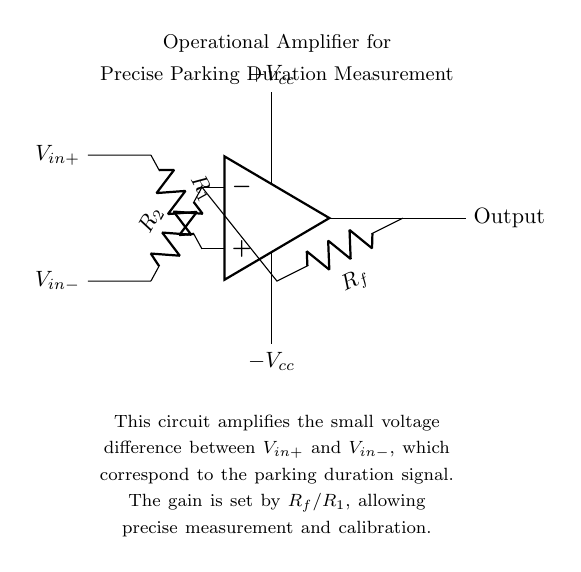What components are in the circuit? The circuit includes an operational amplifier, two resistors R1 and R2, and a feedback resistor Rf.
Answer: operational amplifier, R1, R2, Rf What is Vcc? Vcc refers to the positive power supply voltage connected to the operational amplifier's positive terminal.
Answer: positive power supply voltage What does the feedback resistor Rf do? Rf provides feedback to the inverting input of the operational amplifier, determining the gain of the amplifier.
Answer: determines the gain How is the gain of the amplifier calculated? The gain is calculated using the formula Rf divided by R1, where Rf is the feedback resistor and R1 is the resistor connected to the non-inverting input.
Answer: Rf/R1 What is the purpose of this circuit? The purpose is to amplify the voltage difference corresponding to parking duration for precise measurement.
Answer: amplify parking duration signal How does the output relate to the input? The output voltage from the operational amplifier reflects the amplified difference between the input voltages V_in+ and V_in-.
Answer: amplified difference between V_in+ and V_in- What is the role of the resistors R1 and R2? R1 and R2 set the input conditions for the non-inverting and inverting terminals of the operational amplifier, affecting the overall gain and stability of the circuit.
Answer: set input conditions 